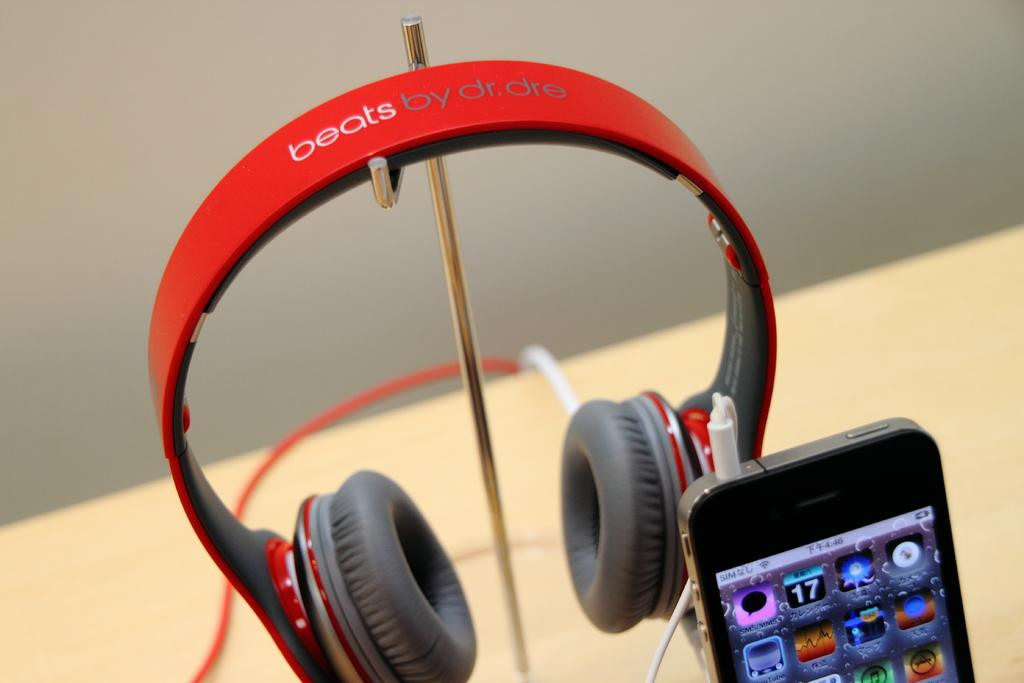What is placed on the stand in the image? There are headphones on a stand in the image. What electronic device can be seen in the bottom right of the image? There is a phone in the bottom right of the image. Can you describe the background of the image? The background of the image is blurred. What type of underwear is visible on the headphones in the image? There is no underwear present in the image; it features headphones on a stand and a phone. What nation is represented by the flag in the image? There is no flag present in the image. How many ladybugs can be seen crawling on the phone in the image? There are no ladybugs present in the image; it features headphones on a stand and a phone. 